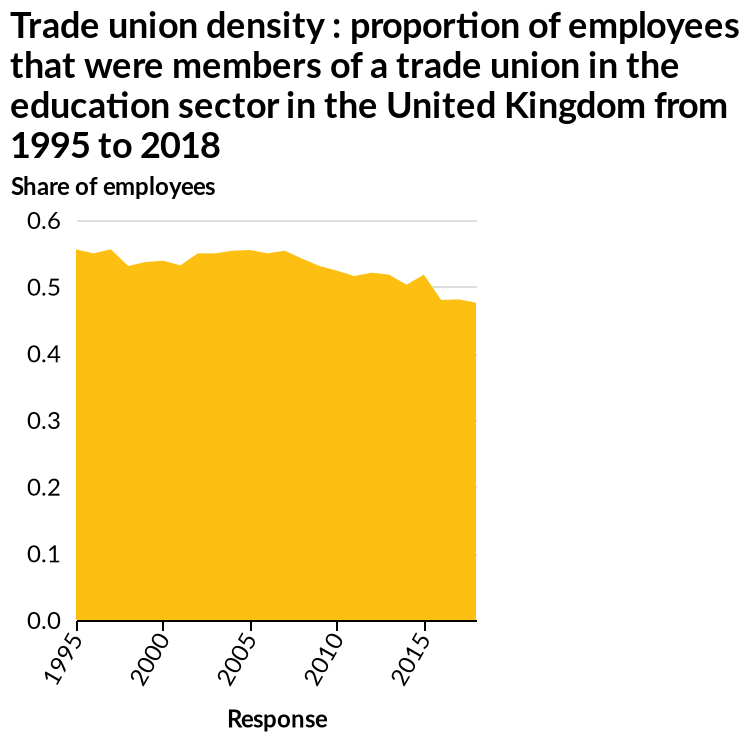<image>
What was the trend of the value over the years?  The value has remained quite steady over the years. How does the value in 2015 compare to previous years? The value in 2015 is significantly lower compared to previous years. Describe the following image in detail Here a is a area diagram titled Trade union density : proportion of employees that were members of a trade union in the education sector in the United Kingdom from 1995 to 2018. The x-axis measures Response while the y-axis measures Share of employees. Offer a thorough analysis of the image. Over the years it has kept quite steady however in 2015 it is at its lowest. Has the value fluctuated significantly over time?  No, the value has remained quite steady over the years. 